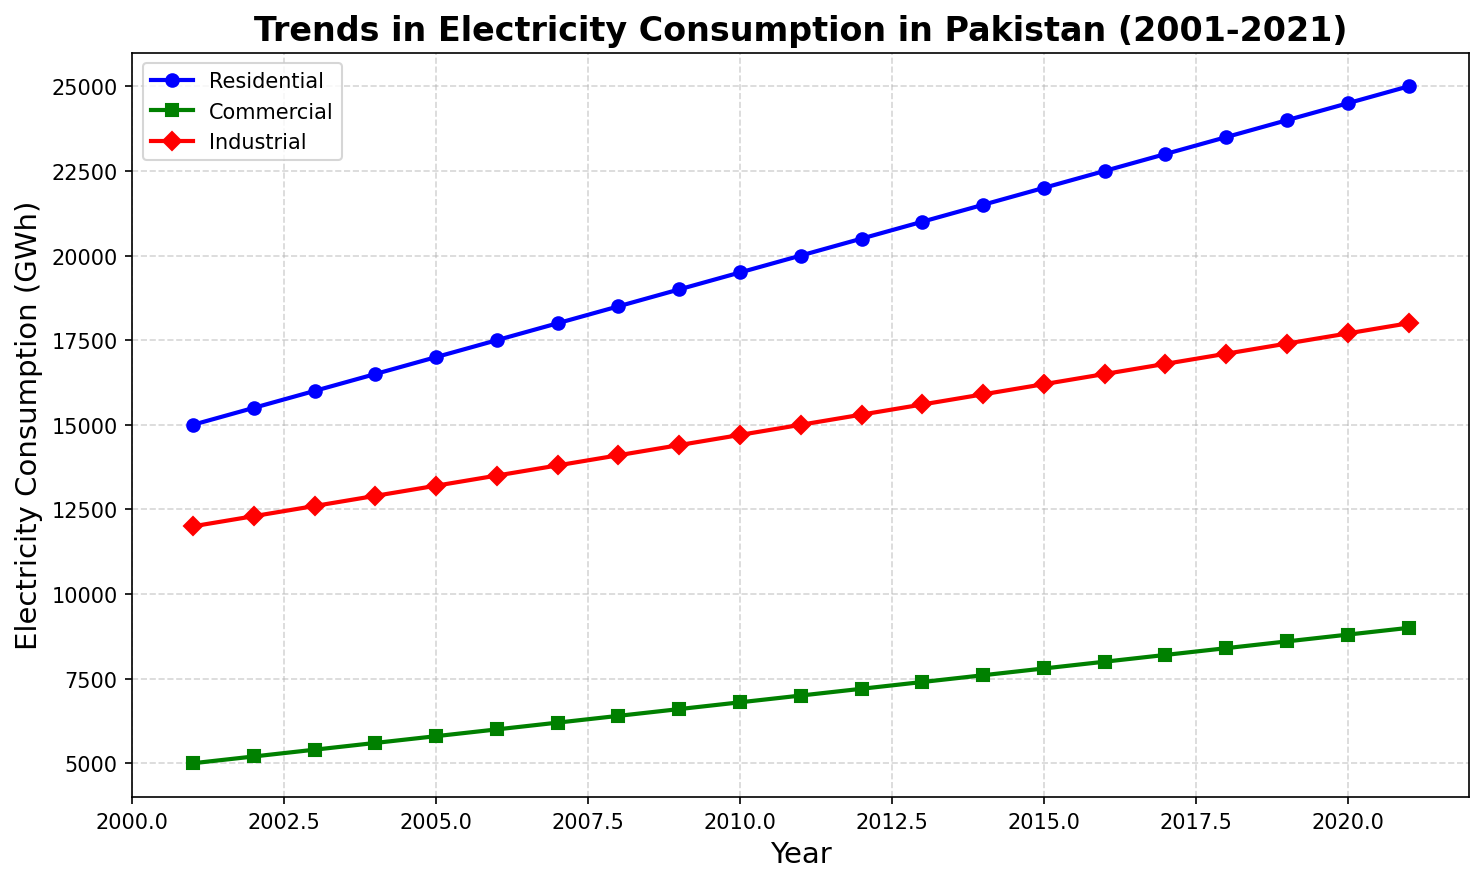Which sector has the highest electricity consumption in 2021? To answer this, we look at the endpoints of the lines corresponding to each sector on the plot. The line for the Industrial sector reaches the highest point in 2021.
Answer: Industrial What was the electricity consumption by the Commercial sector in 2005? Identify the place where the line representing the Commercial sector intersects with the year 2005 on the x-axis. The value at this point is the consumption.
Answer: 5800 GWh Compare the growth in electricity consumption between the Residential and Industrial sectors from 2001 to 2021. Which sector grew more? Subtract the 2001 value of each sector from its 2021 value and then compare the results. For Residential: 25000 - 15000 = 10000 GWh, for Industrial: 18000 - 12000 = 6000 GWh.
Answer: Residential What is the average electricity consumption by the Residential sector over the two decades? Sum the electricity consumption values for the Residential sector from 2001 to 2021 and then divide by the number of years (21). (15000 + 15500 + 16000 + ... + 25000) / 21.
Answer: 20000 GWh Which year shows the largest increase in electricity consumption in the Commercial sector compared to the previous year? Calculate the differences between consecutive years for the Commercial sector and identify the year with the largest difference. The largest increase is from 2019 to 2020:  8800 - 8600 = 200
Answer: 2020 How does the electricity consumption in the Industrial sector in 2010 compare to the consumption in the Residential sector in the same year? Identify the values for both sectors in 2010 and compare them. The Industrial sector in 2010 was at 14700 GWh, while the Residential sector was at 19500 GWh.
Answer: Residential > Industrial What is the trend of electricity consumption in the Commercial sector from 2001 to 2021? Assess the visual slope of the line representing the Commercial sector. Since it rises steadily from 2001 to 2021, it shows an increasing trend.
Answer: Increasing Which sector has the least variation in electricity consumption over the years? Identify the sector with the flattest line or least steep slope on the visual plot. The Commercial sector shows the least variation as its line is the least steep.
Answer: Commercial How much more electricity did the Residential sector consume in 2021 compared to the Commercial sector in 2021? Subtract the Commercial sector's 2021 value (9000 GWh) from the Residential sector's 2021 value (25000 GWh). 25000 - 9000 = 16000 GWh.
Answer: 16000 GWh Between which two consecutive years did the Residential sector experience the smallest increase in electricity consumption? Calculate the differences in the Residential sector’s values between consecutive years and find the smallest difference. The smallest increase is between 2017 and 2018: 23500 - 23000 = 500.
Answer: 2017-2018 